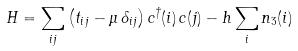<formula> <loc_0><loc_0><loc_500><loc_500>H = \sum _ { i j } \left ( t _ { i j } - \mu \, \delta _ { i j } \right ) c ^ { \dagger } ( i ) \, c ( j ) - h \sum _ { i } n _ { 3 } ( i )</formula> 